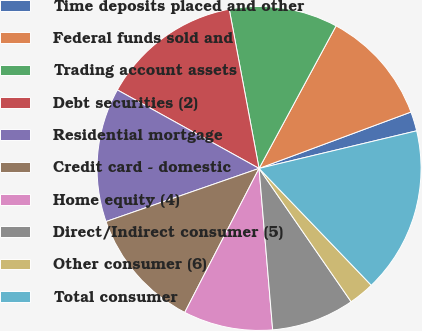Convert chart to OTSL. <chart><loc_0><loc_0><loc_500><loc_500><pie_chart><fcel>Time deposits placed and other<fcel>Federal funds sold and<fcel>Trading account assets<fcel>Debt securities (2)<fcel>Residential mortgage<fcel>Credit card - domestic<fcel>Home equity (4)<fcel>Direct/Indirect consumer (5)<fcel>Other consumer (6)<fcel>Total consumer<nl><fcel>1.93%<fcel>11.46%<fcel>10.83%<fcel>14.0%<fcel>13.37%<fcel>12.1%<fcel>8.92%<fcel>8.28%<fcel>2.56%<fcel>16.55%<nl></chart> 